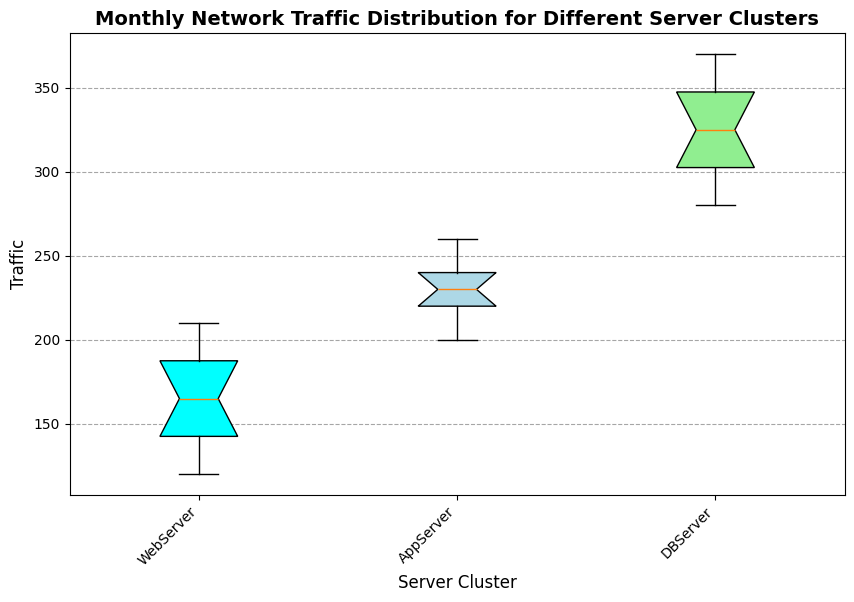What's the median traffic value for the WebServer cluster in January? The median is the middle value in an ordered list. For WebServer in January, the traffic values are 120, 130, 140, 150, and 160. The middle value is 140.
Answer: 140 Which server cluster has the highest median traffic in January? To determine this, compare the median traffic values of each server cluster in January. The medians are 140 for WebServer, 290 for DBServer, and 240 for AppServer. The highest median value is 290 for DBServer.
Answer: DBServer What's the interquartile range (IQR) for the DBServer cluster in February? The IQR is the difference between Q3 (third quartile) and Q1 (first quartile). For DBServer in February, traffic values are 330, 340, 350, 360, and 370. Q1 is 340 and Q3 is 360. The IQR is 360 - 340 = 20.
Answer: 20 Which server cluster has a greater range of traffic values in February, WebServer or AppServer? The range is the difference between the maximum and minimum values. For WebServer in February, range = 210 - 170 = 40. For AppServer in February, range = 240 - 200 = 40. Both clusters have the same range of 40.
Answer: Both What color is the box for the WebServer cluster? The box for WebServer can be identified by its position and comparing with other boxes. The WebServer's box color is cyan.
Answer: cyan Which month shows a greater variability in traffic for the DBServer cluster? Variability can be assessed by comparing the range or IQR of traffic values in both months. For January, the IQR is 310 - 290 = 20 and the range is 320 - 280 = 40. For February, the IQR is 360 - 340 = 20 and the range is 370 - 330 = 40. Both months have equal variability.
Answer: Both 